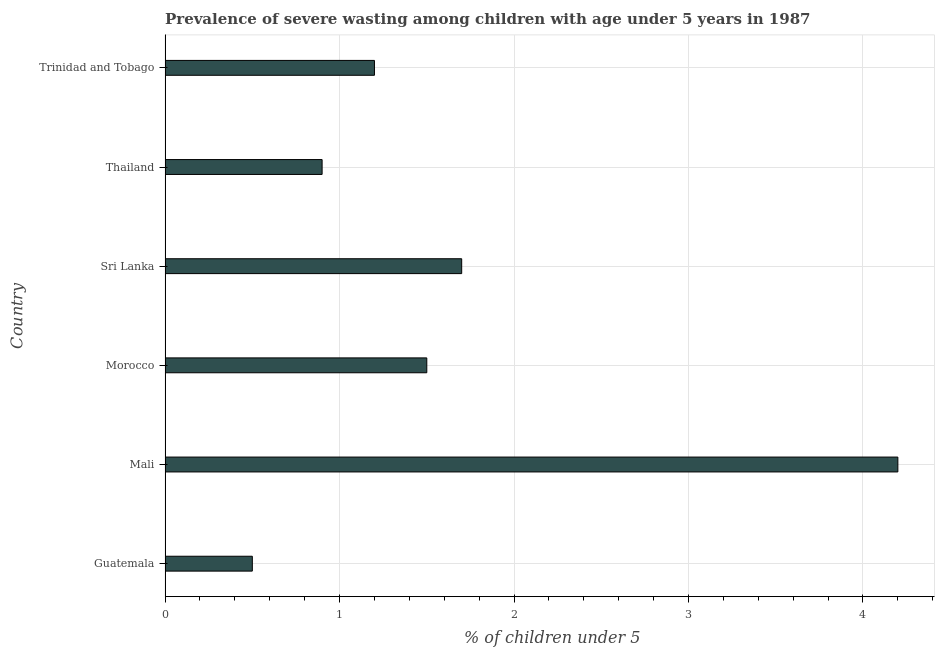Does the graph contain any zero values?
Ensure brevity in your answer.  No. What is the title of the graph?
Give a very brief answer. Prevalence of severe wasting among children with age under 5 years in 1987. What is the label or title of the X-axis?
Ensure brevity in your answer.   % of children under 5. What is the prevalence of severe wasting in Morocco?
Give a very brief answer. 1.5. Across all countries, what is the maximum prevalence of severe wasting?
Give a very brief answer. 4.2. In which country was the prevalence of severe wasting maximum?
Provide a short and direct response. Mali. In which country was the prevalence of severe wasting minimum?
Keep it short and to the point. Guatemala. What is the sum of the prevalence of severe wasting?
Ensure brevity in your answer.  10. What is the difference between the prevalence of severe wasting in Sri Lanka and Trinidad and Tobago?
Make the answer very short. 0.5. What is the average prevalence of severe wasting per country?
Your answer should be compact. 1.67. What is the median prevalence of severe wasting?
Offer a terse response. 1.35. In how many countries, is the prevalence of severe wasting greater than 2.8 %?
Your answer should be compact. 1. What is the ratio of the prevalence of severe wasting in Guatemala to that in Mali?
Offer a terse response. 0.12. Is the prevalence of severe wasting in Guatemala less than that in Morocco?
Provide a succinct answer. Yes. Is the difference between the prevalence of severe wasting in Mali and Morocco greater than the difference between any two countries?
Keep it short and to the point. No. What is the difference between the highest and the lowest prevalence of severe wasting?
Provide a short and direct response. 3.7. In how many countries, is the prevalence of severe wasting greater than the average prevalence of severe wasting taken over all countries?
Provide a succinct answer. 2. How many bars are there?
Give a very brief answer. 6. Are all the bars in the graph horizontal?
Your answer should be compact. Yes. How many countries are there in the graph?
Your answer should be compact. 6. What is the difference between two consecutive major ticks on the X-axis?
Keep it short and to the point. 1. What is the  % of children under 5 in Mali?
Provide a short and direct response. 4.2. What is the  % of children under 5 in Sri Lanka?
Provide a short and direct response. 1.7. What is the  % of children under 5 in Thailand?
Provide a short and direct response. 0.9. What is the  % of children under 5 in Trinidad and Tobago?
Keep it short and to the point. 1.2. What is the difference between the  % of children under 5 in Guatemala and Sri Lanka?
Make the answer very short. -1.2. What is the difference between the  % of children under 5 in Guatemala and Thailand?
Ensure brevity in your answer.  -0.4. What is the difference between the  % of children under 5 in Mali and Sri Lanka?
Make the answer very short. 2.5. What is the difference between the  % of children under 5 in Mali and Thailand?
Your answer should be compact. 3.3. What is the difference between the  % of children under 5 in Mali and Trinidad and Tobago?
Keep it short and to the point. 3. What is the difference between the  % of children under 5 in Morocco and Sri Lanka?
Your answer should be very brief. -0.2. What is the difference between the  % of children under 5 in Sri Lanka and Thailand?
Keep it short and to the point. 0.8. What is the difference between the  % of children under 5 in Sri Lanka and Trinidad and Tobago?
Provide a short and direct response. 0.5. What is the difference between the  % of children under 5 in Thailand and Trinidad and Tobago?
Give a very brief answer. -0.3. What is the ratio of the  % of children under 5 in Guatemala to that in Mali?
Provide a short and direct response. 0.12. What is the ratio of the  % of children under 5 in Guatemala to that in Morocco?
Your answer should be compact. 0.33. What is the ratio of the  % of children under 5 in Guatemala to that in Sri Lanka?
Ensure brevity in your answer.  0.29. What is the ratio of the  % of children under 5 in Guatemala to that in Thailand?
Keep it short and to the point. 0.56. What is the ratio of the  % of children under 5 in Guatemala to that in Trinidad and Tobago?
Your answer should be compact. 0.42. What is the ratio of the  % of children under 5 in Mali to that in Sri Lanka?
Keep it short and to the point. 2.47. What is the ratio of the  % of children under 5 in Mali to that in Thailand?
Offer a terse response. 4.67. What is the ratio of the  % of children under 5 in Mali to that in Trinidad and Tobago?
Your answer should be compact. 3.5. What is the ratio of the  % of children under 5 in Morocco to that in Sri Lanka?
Offer a terse response. 0.88. What is the ratio of the  % of children under 5 in Morocco to that in Thailand?
Offer a very short reply. 1.67. What is the ratio of the  % of children under 5 in Morocco to that in Trinidad and Tobago?
Keep it short and to the point. 1.25. What is the ratio of the  % of children under 5 in Sri Lanka to that in Thailand?
Make the answer very short. 1.89. What is the ratio of the  % of children under 5 in Sri Lanka to that in Trinidad and Tobago?
Offer a terse response. 1.42. What is the ratio of the  % of children under 5 in Thailand to that in Trinidad and Tobago?
Provide a succinct answer. 0.75. 